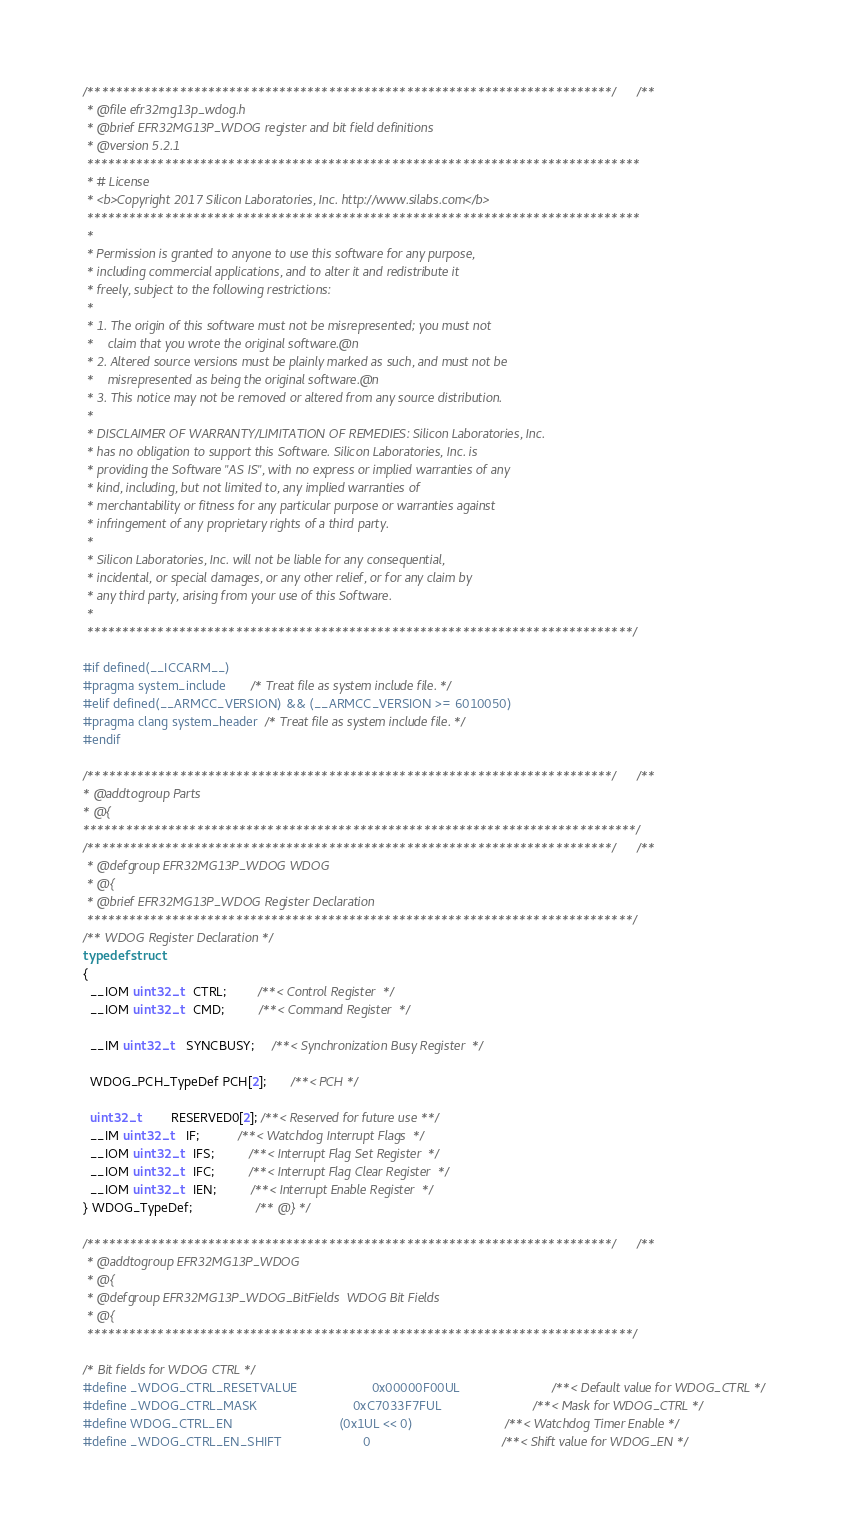<code> <loc_0><loc_0><loc_500><loc_500><_C_>/**************************************************************************//**
 * @file efr32mg13p_wdog.h
 * @brief EFR32MG13P_WDOG register and bit field definitions
 * @version 5.2.1
 ******************************************************************************
 * # License
 * <b>Copyright 2017 Silicon Laboratories, Inc. http://www.silabs.com</b>
 ******************************************************************************
 *
 * Permission is granted to anyone to use this software for any purpose,
 * including commercial applications, and to alter it and redistribute it
 * freely, subject to the following restrictions:
 *
 * 1. The origin of this software must not be misrepresented; you must not
 *    claim that you wrote the original software.@n
 * 2. Altered source versions must be plainly marked as such, and must not be
 *    misrepresented as being the original software.@n
 * 3. This notice may not be removed or altered from any source distribution.
 *
 * DISCLAIMER OF WARRANTY/LIMITATION OF REMEDIES: Silicon Laboratories, Inc.
 * has no obligation to support this Software. Silicon Laboratories, Inc. is
 * providing the Software "AS IS", with no express or implied warranties of any
 * kind, including, but not limited to, any implied warranties of
 * merchantability or fitness for any particular purpose or warranties against
 * infringement of any proprietary rights of a third party.
 *
 * Silicon Laboratories, Inc. will not be liable for any consequential,
 * incidental, or special damages, or any other relief, or for any claim by
 * any third party, arising from your use of this Software.
 *
 *****************************************************************************/

#if defined(__ICCARM__)
#pragma system_include       /* Treat file as system include file. */
#elif defined(__ARMCC_VERSION) && (__ARMCC_VERSION >= 6010050)
#pragma clang system_header  /* Treat file as system include file. */
#endif

/**************************************************************************//**
* @addtogroup Parts
* @{
******************************************************************************/
/**************************************************************************//**
 * @defgroup EFR32MG13P_WDOG WDOG
 * @{
 * @brief EFR32MG13P_WDOG Register Declaration
 *****************************************************************************/
/** WDOG Register Declaration */
typedef struct
{
  __IOM uint32_t   CTRL;         /**< Control Register  */
  __IOM uint32_t   CMD;          /**< Command Register  */

  __IM uint32_t    SYNCBUSY;     /**< Synchronization Busy Register  */

  WDOG_PCH_TypeDef PCH[2];       /**< PCH */

  uint32_t         RESERVED0[2]; /**< Reserved for future use **/
  __IM uint32_t    IF;           /**< Watchdog Interrupt Flags  */
  __IOM uint32_t   IFS;          /**< Interrupt Flag Set Register  */
  __IOM uint32_t   IFC;          /**< Interrupt Flag Clear Register  */
  __IOM uint32_t   IEN;          /**< Interrupt Enable Register  */
} WDOG_TypeDef;                  /** @} */

/**************************************************************************//**
 * @addtogroup EFR32MG13P_WDOG
 * @{
 * @defgroup EFR32MG13P_WDOG_BitFields  WDOG Bit Fields
 * @{
 *****************************************************************************/

/* Bit fields for WDOG CTRL */
#define _WDOG_CTRL_RESETVALUE                     0x00000F00UL                          /**< Default value for WDOG_CTRL */
#define _WDOG_CTRL_MASK                           0xC7033F7FUL                          /**< Mask for WDOG_CTRL */
#define WDOG_CTRL_EN                              (0x1UL << 0)                          /**< Watchdog Timer Enable */
#define _WDOG_CTRL_EN_SHIFT                       0                                     /**< Shift value for WDOG_EN */</code> 